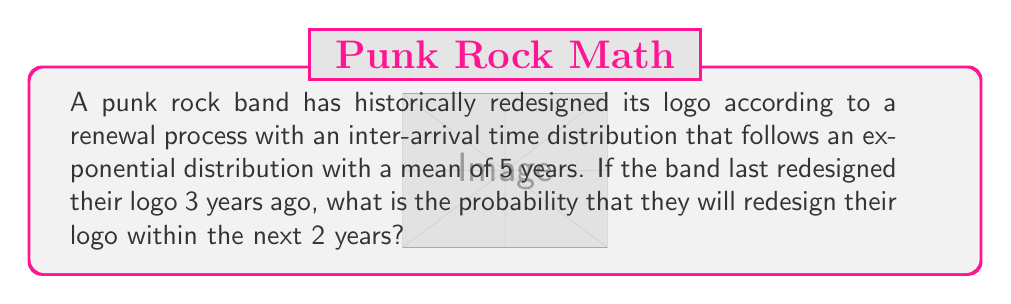Could you help me with this problem? Let's approach this step-by-step:

1) In a renewal process with exponentially distributed inter-arrival times, the time until the next event (in this case, a logo redesign) follows the same exponential distribution, regardless of how much time has passed since the last event. This is due to the memoryless property of the exponential distribution.

2) Given:
   - The inter-arrival times follow an exponential distribution
   - The mean time between redesigns is 5 years
   - It has been 3 years since the last redesign
   - We want to find the probability of a redesign within the next 2 years

3) For an exponential distribution, the rate parameter $\lambda$ is the inverse of the mean. So:

   $\lambda = \frac{1}{5} = 0.2$ per year

4) The probability of the event occurring within time $t$ for an exponential distribution is given by:

   $P(T \leq t) = 1 - e^{-\lambda t}$

5) In this case, $t = 2$ years (the time window we're interested in). So we need to calculate:

   $P(T \leq 2) = 1 - e^{-0.2 * 2}$

6) Solving this:

   $P(T \leq 2) = 1 - e^{-0.4}$
   $= 1 - 0.6703$
   $\approx 0.3297$

Therefore, the probability that the band will redesign their logo within the next 2 years is approximately 0.3297 or 32.97%.
Answer: 0.3297 